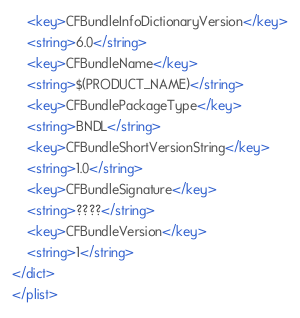<code> <loc_0><loc_0><loc_500><loc_500><_XML_>	<key>CFBundleInfoDictionaryVersion</key>
	<string>6.0</string>
	<key>CFBundleName</key>
	<string>$(PRODUCT_NAME)</string>
	<key>CFBundlePackageType</key>
	<string>BNDL</string>
	<key>CFBundleShortVersionString</key>
	<string>1.0</string>
	<key>CFBundleSignature</key>
	<string>????</string>
	<key>CFBundleVersion</key>
	<string>1</string>
</dict>
</plist>
</code> 